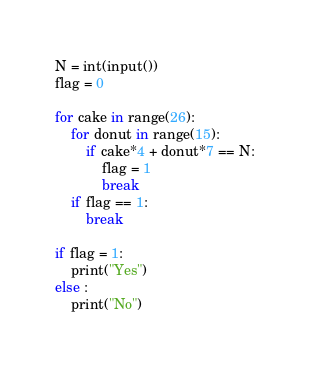<code> <loc_0><loc_0><loc_500><loc_500><_Python_>N = int(input())
flag = 0

for cake in range(26):
    for donut in range(15):
        if cake*4 + donut*7 == N:
            flag = 1
            break
    if flag == 1:
        break

if flag = 1:
    print("Yes")
else :
    print("No")
</code> 